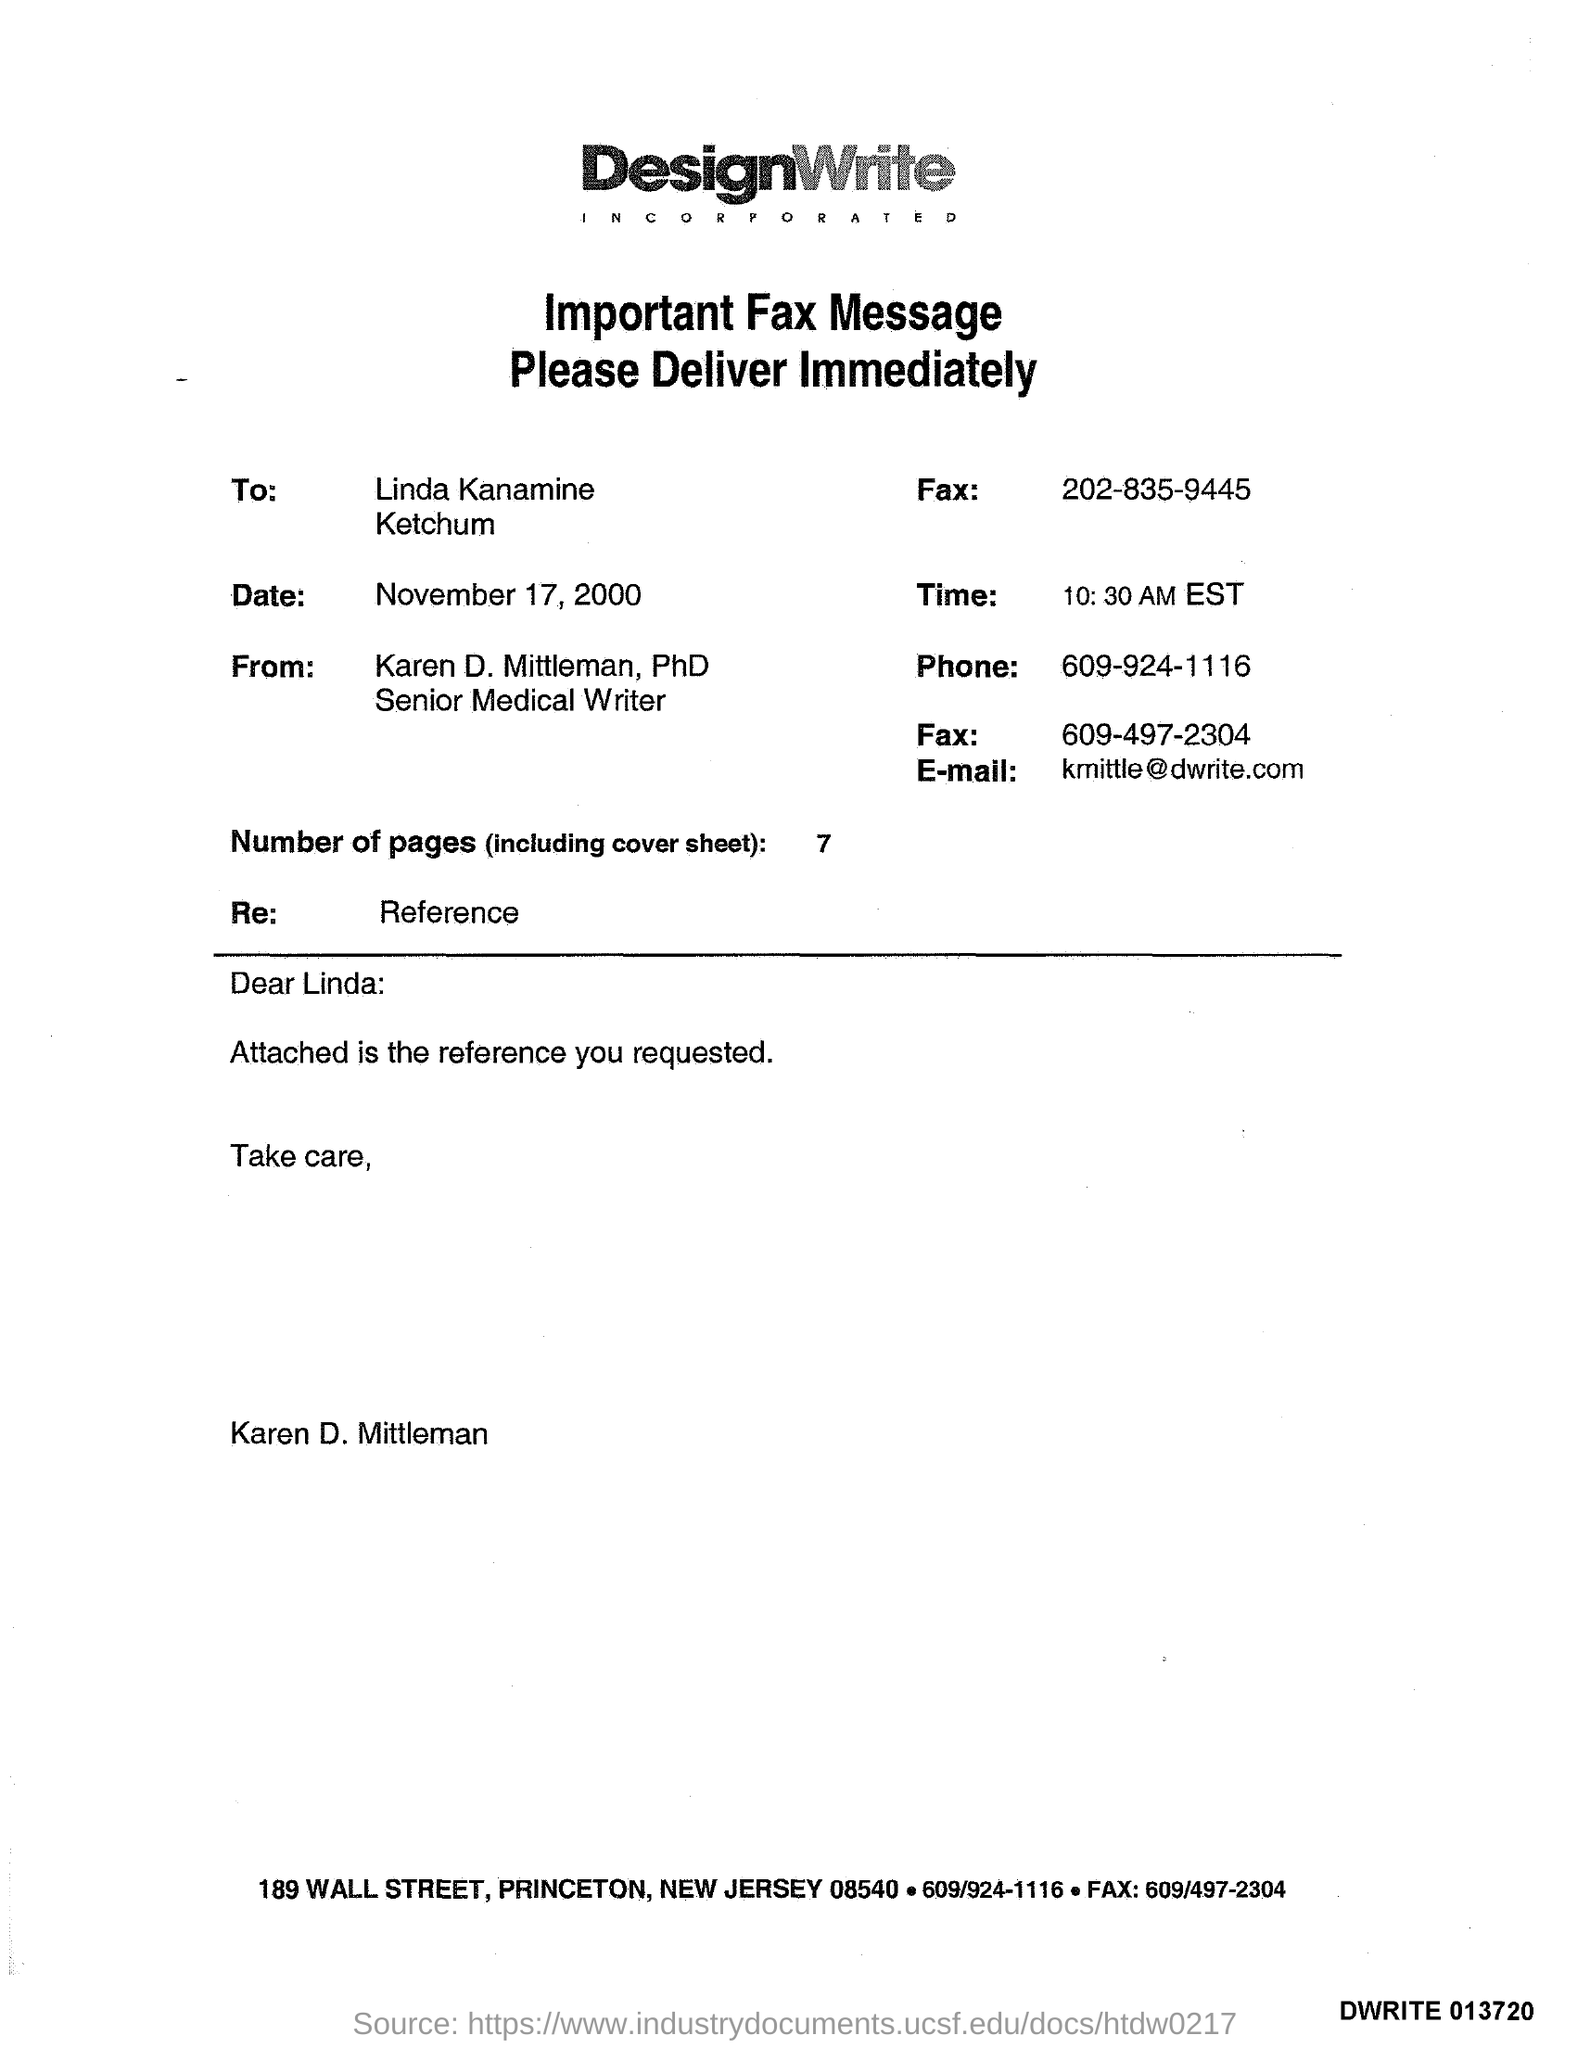List a handful of essential elements in this visual. Seven is the number of pages. It is 10:30 AM, and the current time is Eastern Standard Time. The phone number is 609-924-1116. The email address is [kmittle@dwrite.com](mailto:kmittle@dwrite.com). 